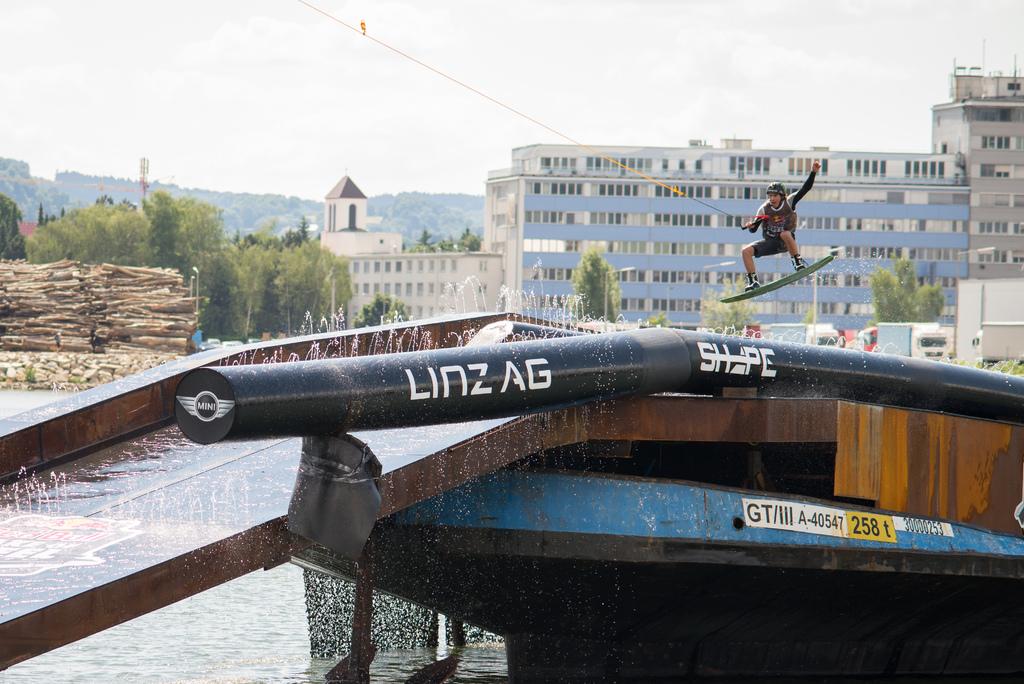Was the rail made by "mini"?
Provide a short and direct response. Yes. What number has the yellow background?
Make the answer very short. 258. 